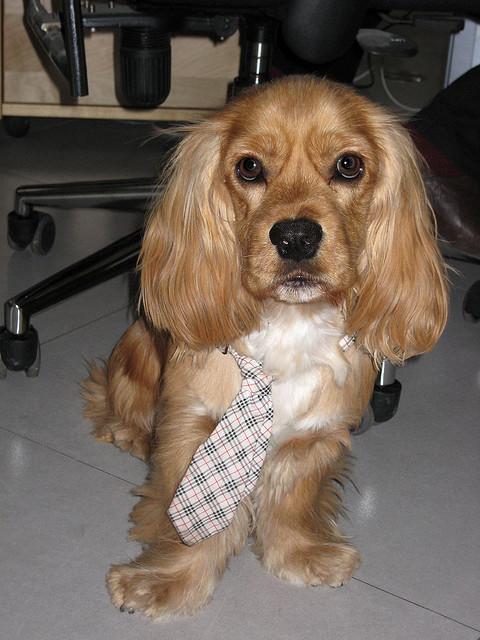Is this dog wearing his tags?
Quick response, please. No. What is the dog sitting on?
Short answer required. Floor. Where is the dog's tie?
Be succinct. Around his neck. How many puppies?
Be succinct. 1. 